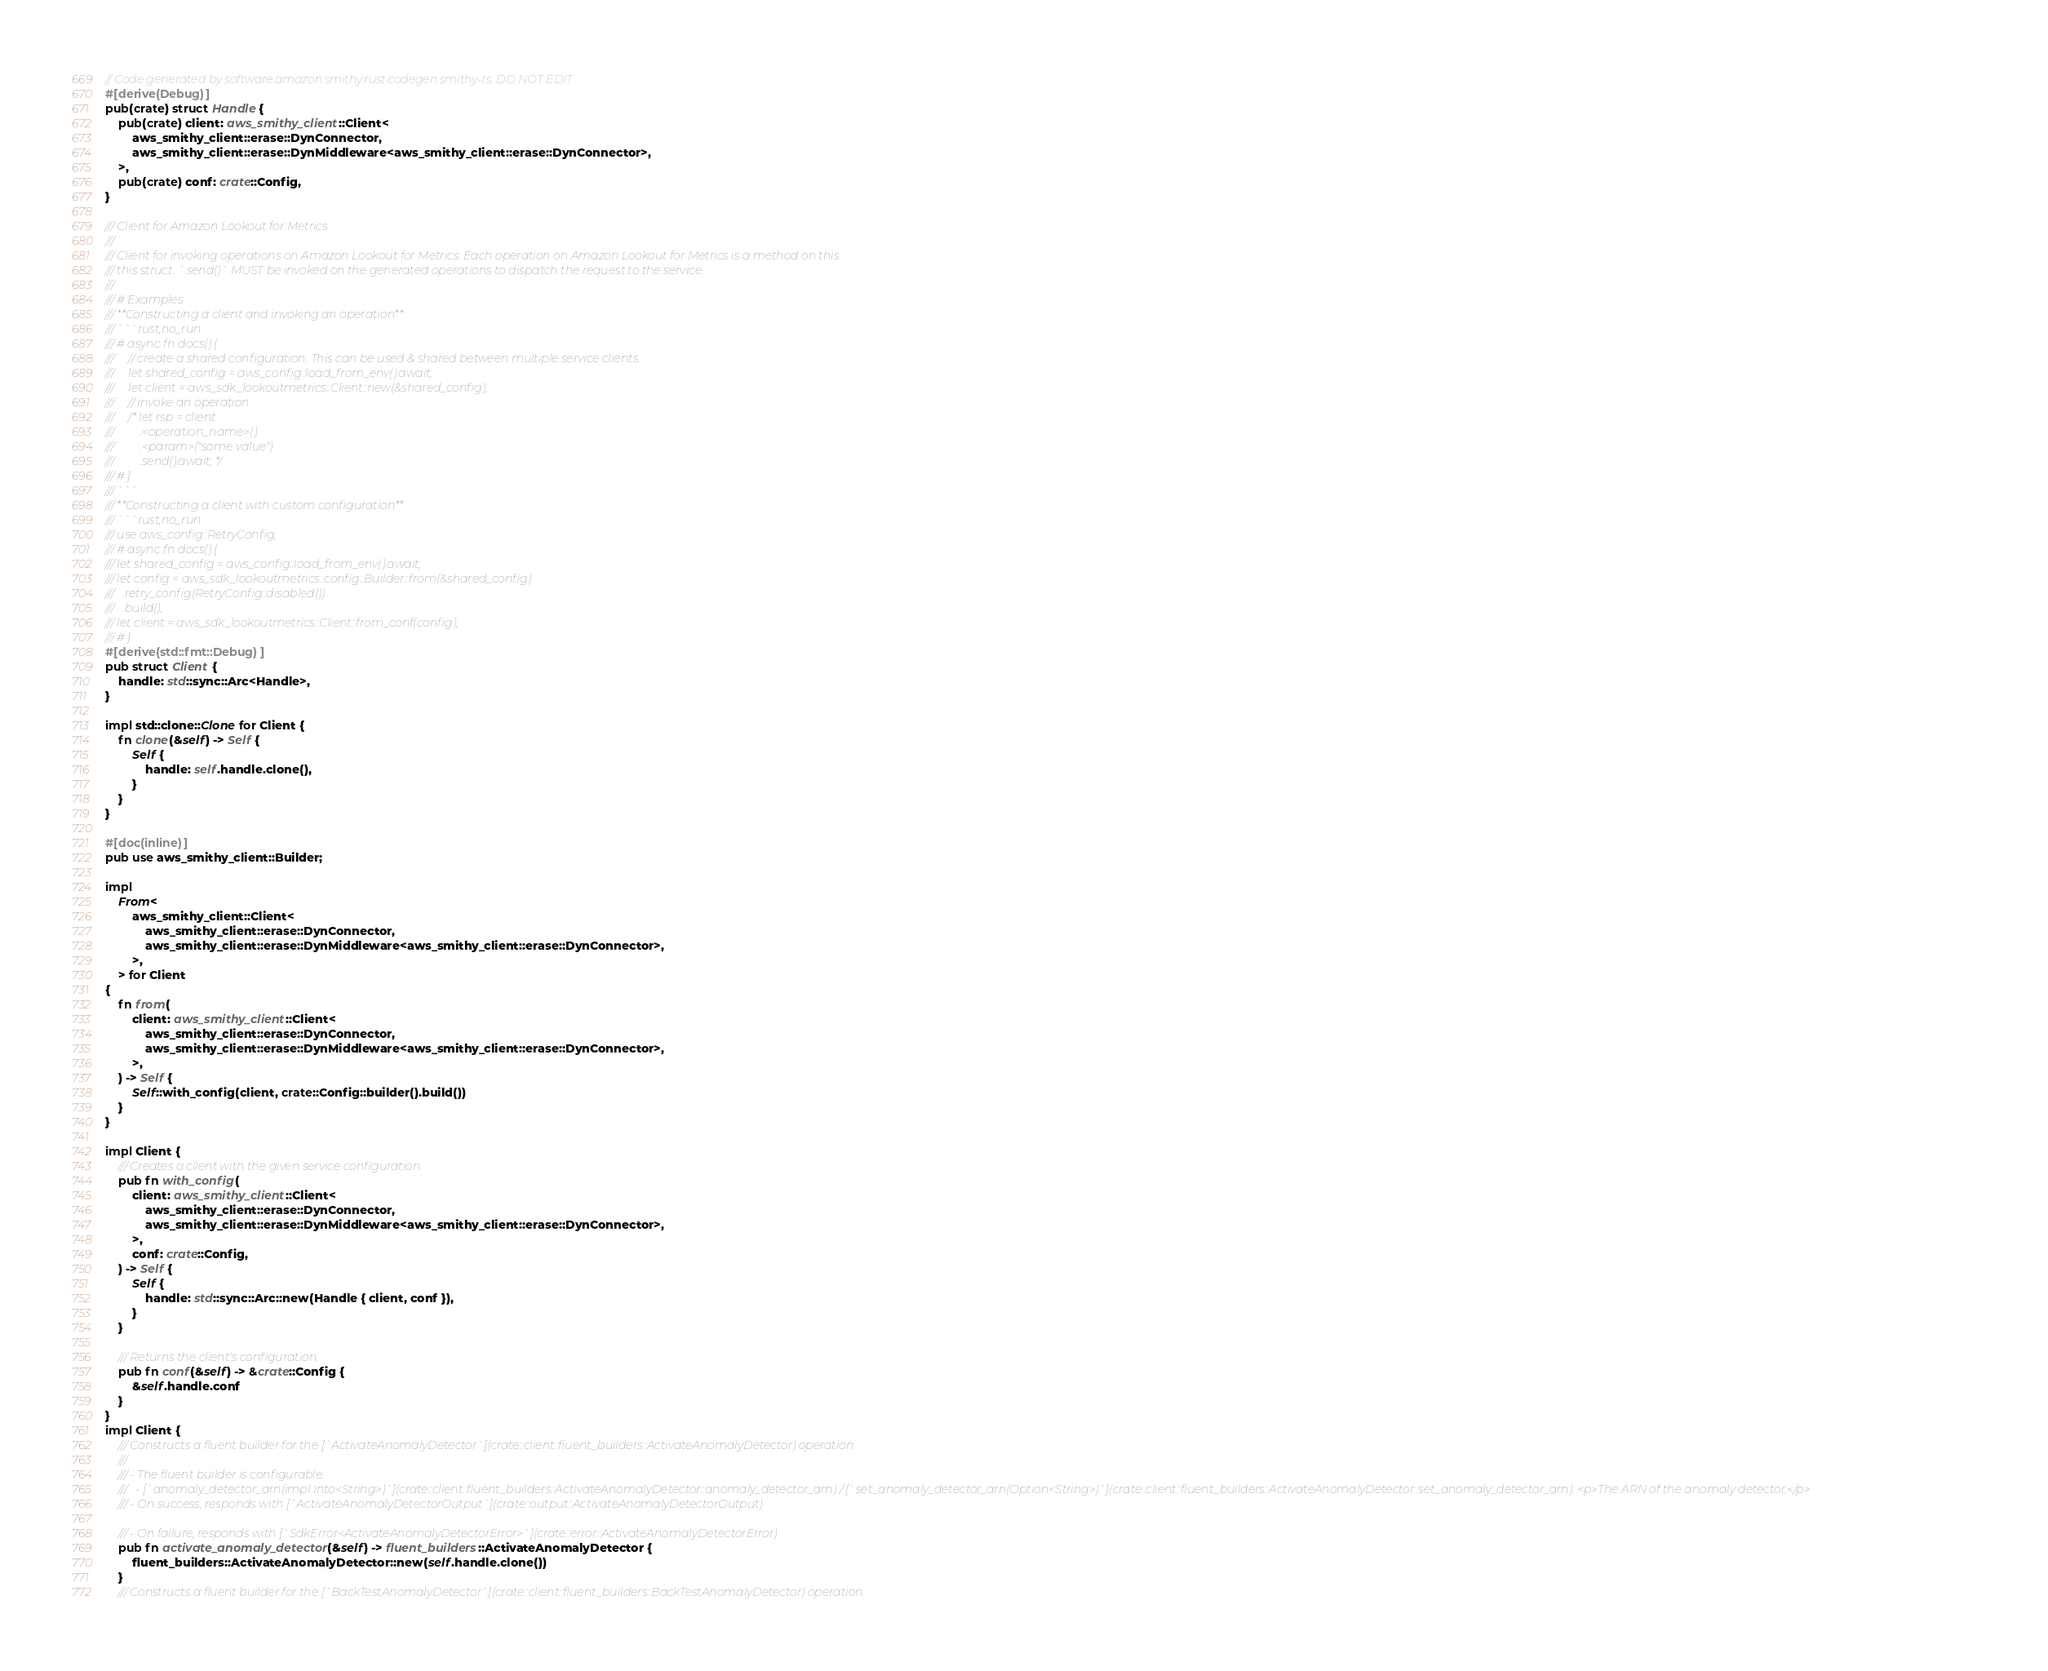Convert code to text. <code><loc_0><loc_0><loc_500><loc_500><_Rust_>// Code generated by software.amazon.smithy.rust.codegen.smithy-rs. DO NOT EDIT.
#[derive(Debug)]
pub(crate) struct Handle {
    pub(crate) client: aws_smithy_client::Client<
        aws_smithy_client::erase::DynConnector,
        aws_smithy_client::erase::DynMiddleware<aws_smithy_client::erase::DynConnector>,
    >,
    pub(crate) conf: crate::Config,
}

/// Client for Amazon Lookout for Metrics
///
/// Client for invoking operations on Amazon Lookout for Metrics. Each operation on Amazon Lookout for Metrics is a method on this
/// this struct. `.send()` MUST be invoked on the generated operations to dispatch the request to the service.
///
/// # Examples
/// **Constructing a client and invoking an operation**
/// ```rust,no_run
/// # async fn docs() {
///     // create a shared configuration. This can be used & shared between multiple service clients.
///     let shared_config = aws_config::load_from_env().await;
///     let client = aws_sdk_lookoutmetrics::Client::new(&shared_config);
///     // invoke an operation
///     /* let rsp = client
///         .<operation_name>().
///         .<param>("some value")
///         .send().await; */
/// # }
/// ```
/// **Constructing a client with custom configuration**
/// ```rust,no_run
/// use aws_config::RetryConfig;
/// # async fn docs() {
/// let shared_config = aws_config::load_from_env().await;
/// let config = aws_sdk_lookoutmetrics::config::Builder::from(&shared_config)
///   .retry_config(RetryConfig::disabled())
///   .build();
/// let client = aws_sdk_lookoutmetrics::Client::from_conf(config);
/// # }
#[derive(std::fmt::Debug)]
pub struct Client {
    handle: std::sync::Arc<Handle>,
}

impl std::clone::Clone for Client {
    fn clone(&self) -> Self {
        Self {
            handle: self.handle.clone(),
        }
    }
}

#[doc(inline)]
pub use aws_smithy_client::Builder;

impl
    From<
        aws_smithy_client::Client<
            aws_smithy_client::erase::DynConnector,
            aws_smithy_client::erase::DynMiddleware<aws_smithy_client::erase::DynConnector>,
        >,
    > for Client
{
    fn from(
        client: aws_smithy_client::Client<
            aws_smithy_client::erase::DynConnector,
            aws_smithy_client::erase::DynMiddleware<aws_smithy_client::erase::DynConnector>,
        >,
    ) -> Self {
        Self::with_config(client, crate::Config::builder().build())
    }
}

impl Client {
    /// Creates a client with the given service configuration.
    pub fn with_config(
        client: aws_smithy_client::Client<
            aws_smithy_client::erase::DynConnector,
            aws_smithy_client::erase::DynMiddleware<aws_smithy_client::erase::DynConnector>,
        >,
        conf: crate::Config,
    ) -> Self {
        Self {
            handle: std::sync::Arc::new(Handle { client, conf }),
        }
    }

    /// Returns the client's configuration.
    pub fn conf(&self) -> &crate::Config {
        &self.handle.conf
    }
}
impl Client {
    /// Constructs a fluent builder for the [`ActivateAnomalyDetector`](crate::client::fluent_builders::ActivateAnomalyDetector) operation.
    ///
    /// - The fluent builder is configurable:
    ///   - [`anomaly_detector_arn(impl Into<String>)`](crate::client::fluent_builders::ActivateAnomalyDetector::anomaly_detector_arn) / [`set_anomaly_detector_arn(Option<String>)`](crate::client::fluent_builders::ActivateAnomalyDetector::set_anomaly_detector_arn): <p>The ARN of the anomaly detector.</p>
    /// - On success, responds with [`ActivateAnomalyDetectorOutput`](crate::output::ActivateAnomalyDetectorOutput)

    /// - On failure, responds with [`SdkError<ActivateAnomalyDetectorError>`](crate::error::ActivateAnomalyDetectorError)
    pub fn activate_anomaly_detector(&self) -> fluent_builders::ActivateAnomalyDetector {
        fluent_builders::ActivateAnomalyDetector::new(self.handle.clone())
    }
    /// Constructs a fluent builder for the [`BackTestAnomalyDetector`](crate::client::fluent_builders::BackTestAnomalyDetector) operation.</code> 